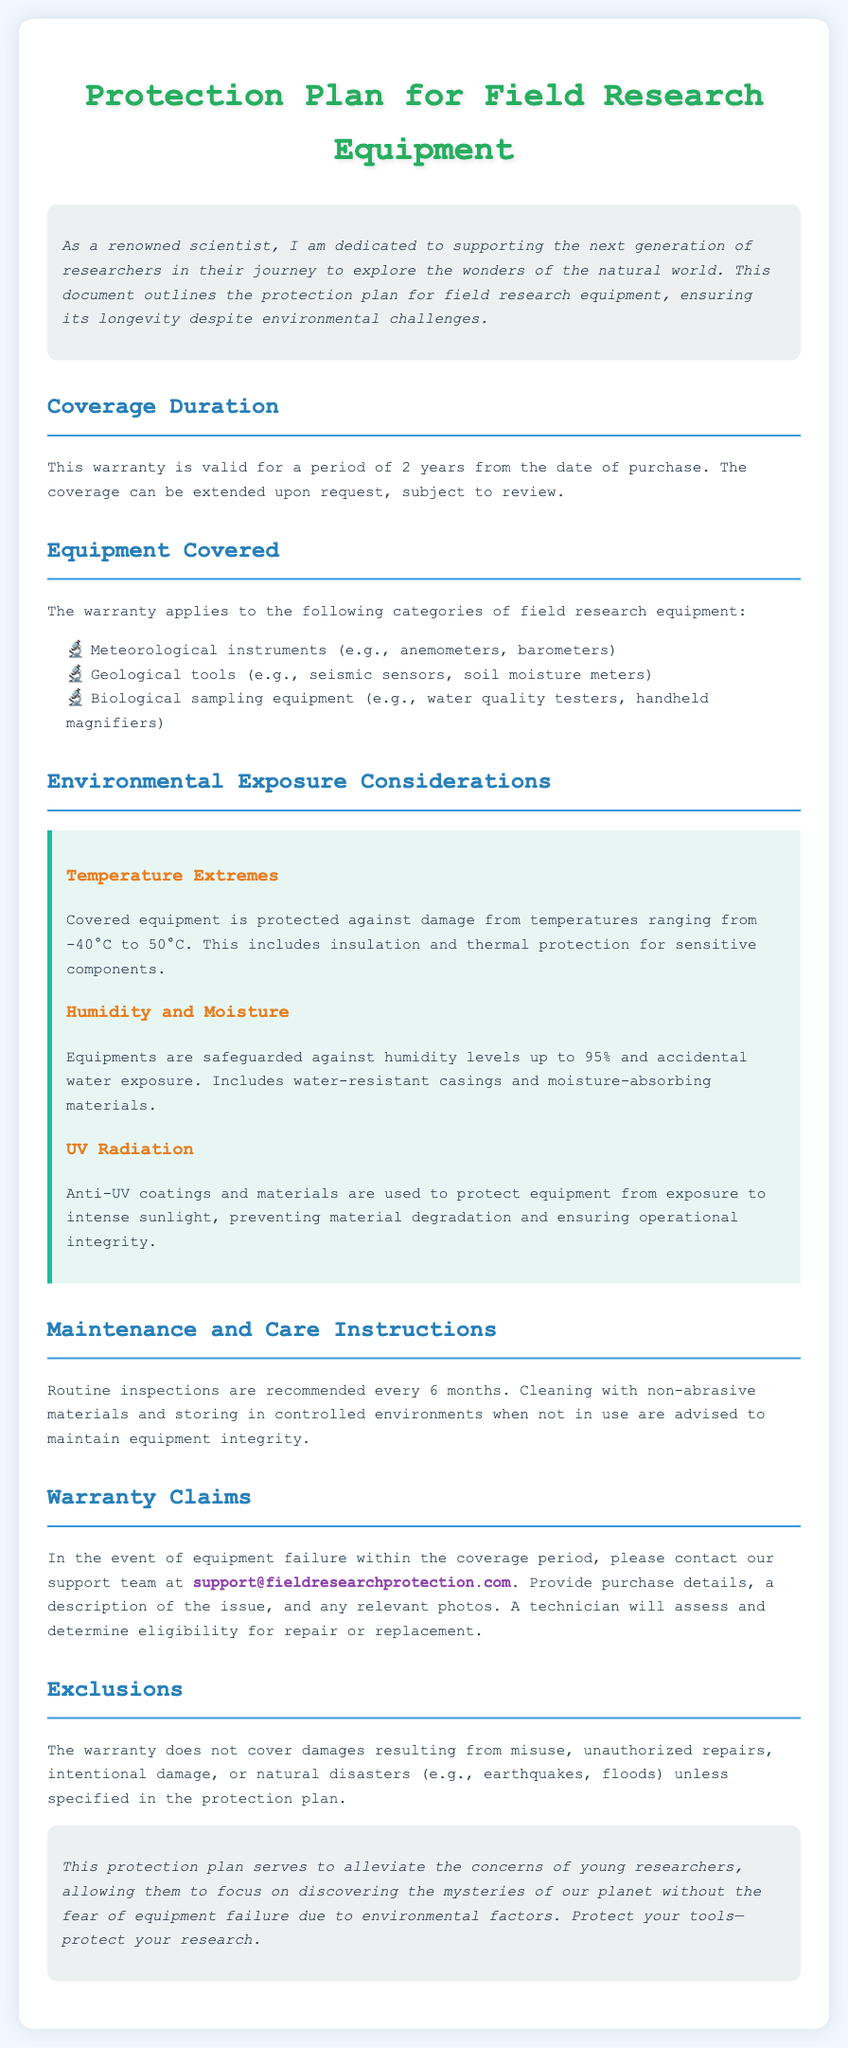What is the duration of the warranty? The warranty is valid for a period of 2 years from the date of purchase.
Answer: 2 years Which environmental exposure is covered under the plan? The document outlines protection against temperature extremes, humidity and moisture, and UV radiation.
Answer: Temperature extremes What types of equipment are included in the warranty? The document lists meteorological instruments, geological tools, and biological sampling equipment.
Answer: Meteorological instruments How often should routine inspections be performed? It is recommended to conduct inspections every 6 months to maintain equipment integrity.
Answer: Every 6 months What is the maximum humidity level covered? The warranty safeguards equipment against humidity levels up to 95%.
Answer: 95% Why does the warranty exclude natural disasters? The warranty does not cover damages resulting from natural disasters unless specified in the protection plan.
Answer: Natural disasters What is the contact email for support claims? The document provides a contact email for warranty claims related to equipment failure.
Answer: support@fieldresearchprotection.com What kind of materials are used for UV protection? Anti-UV coatings and materials are used to protect equipment from UV exposure.
Answer: Anti-UV coatings What action should be taken if equipment fails within the warranty? In the event of failure, one should contact the support team with purchase details and issue description.
Answer: Contact support team 